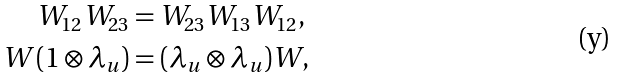<formula> <loc_0><loc_0><loc_500><loc_500>W _ { 1 2 } W _ { 2 3 } & = W _ { 2 3 } W _ { 1 3 } W _ { 1 2 } , \\ W ( 1 \otimes \lambda _ { u } ) & = ( \lambda _ { u } \otimes \lambda _ { u } ) W ,</formula> 